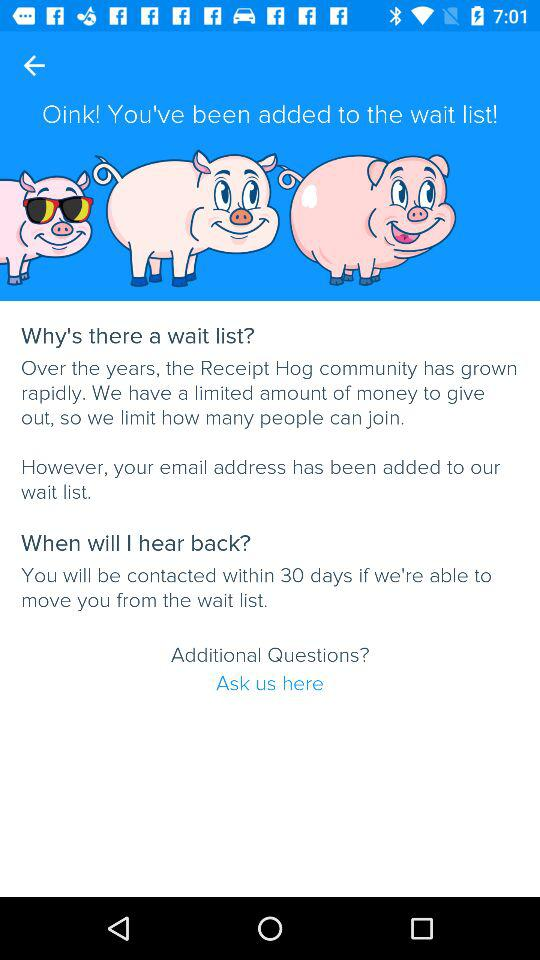Within how many days will they contact us if they are able to move from the wait list? They will be contacted within 30 days. 